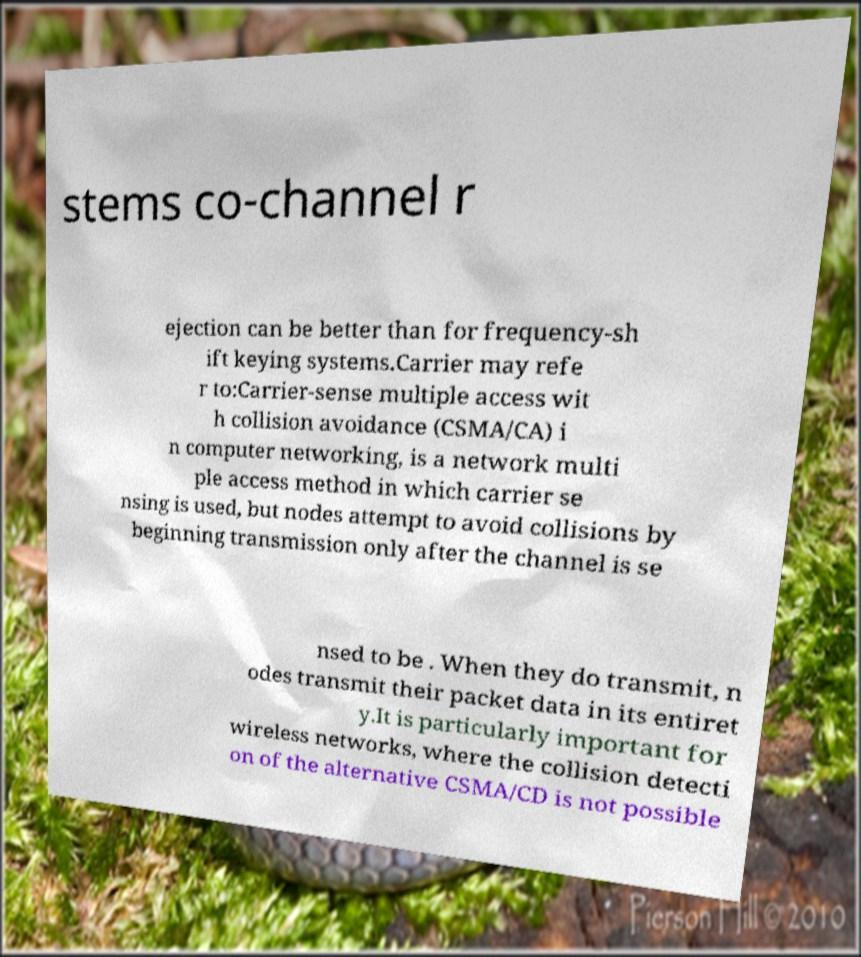Can you accurately transcribe the text from the provided image for me? stems co-channel r ejection can be better than for frequency-sh ift keying systems.Carrier may refe r to:Carrier-sense multiple access wit h collision avoidance (CSMA/CA) i n computer networking, is a network multi ple access method in which carrier se nsing is used, but nodes attempt to avoid collisions by beginning transmission only after the channel is se nsed to be . When they do transmit, n odes transmit their packet data in its entiret y.It is particularly important for wireless networks, where the collision detecti on of the alternative CSMA/CD is not possible 